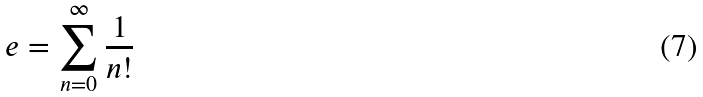Convert formula to latex. <formula><loc_0><loc_0><loc_500><loc_500>e = \sum _ { n = 0 } ^ { \infty } \frac { 1 } { n ! }</formula> 